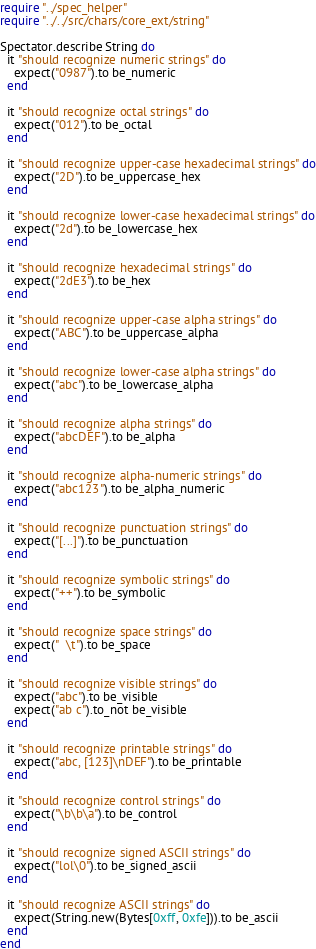<code> <loc_0><loc_0><loc_500><loc_500><_Crystal_>require "../spec_helper"
require "../../src/chars/core_ext/string"

Spectator.describe String do
  it "should recognize numeric strings" do
    expect("0987").to be_numeric
  end

  it "should recognize octal strings" do
    expect("012").to be_octal
  end

  it "should recognize upper-case hexadecimal strings" do
    expect("2D").to be_uppercase_hex
  end

  it "should recognize lower-case hexadecimal strings" do
    expect("2d").to be_lowercase_hex
  end

  it "should recognize hexadecimal strings" do
    expect("2dE3").to be_hex
  end

  it "should recognize upper-case alpha strings" do
    expect("ABC").to be_uppercase_alpha
  end

  it "should recognize lower-case alpha strings" do
    expect("abc").to be_lowercase_alpha
  end

  it "should recognize alpha strings" do
    expect("abcDEF").to be_alpha
  end

  it "should recognize alpha-numeric strings" do
    expect("abc123").to be_alpha_numeric
  end

  it "should recognize punctuation strings" do
    expect("[...]").to be_punctuation
  end

  it "should recognize symbolic strings" do
    expect("++").to be_symbolic
  end

  it "should recognize space strings" do
    expect("  \t").to be_space
  end

  it "should recognize visible strings" do
    expect("abc").to be_visible
    expect("ab c").to_not be_visible
  end

  it "should recognize printable strings" do
    expect("abc, [123]\nDEF").to be_printable
  end

  it "should recognize control strings" do
    expect("\b\b\a").to be_control
  end

  it "should recognize signed ASCII strings" do
    expect("lol\0").to be_signed_ascii
  end

  it "should recognize ASCII strings" do
    expect(String.new(Bytes[0xff, 0xfe])).to be_ascii
  end
end
</code> 